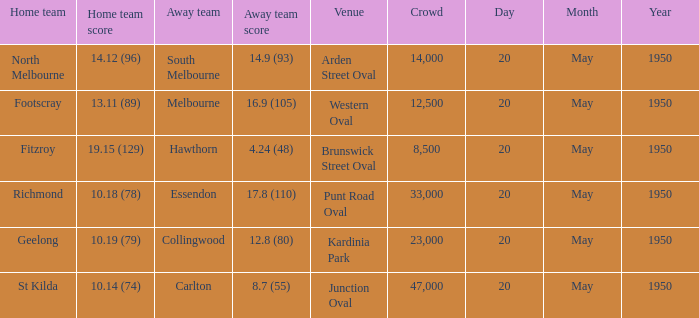At which venue did the away team achieve a score of 1 Arden Street Oval. 